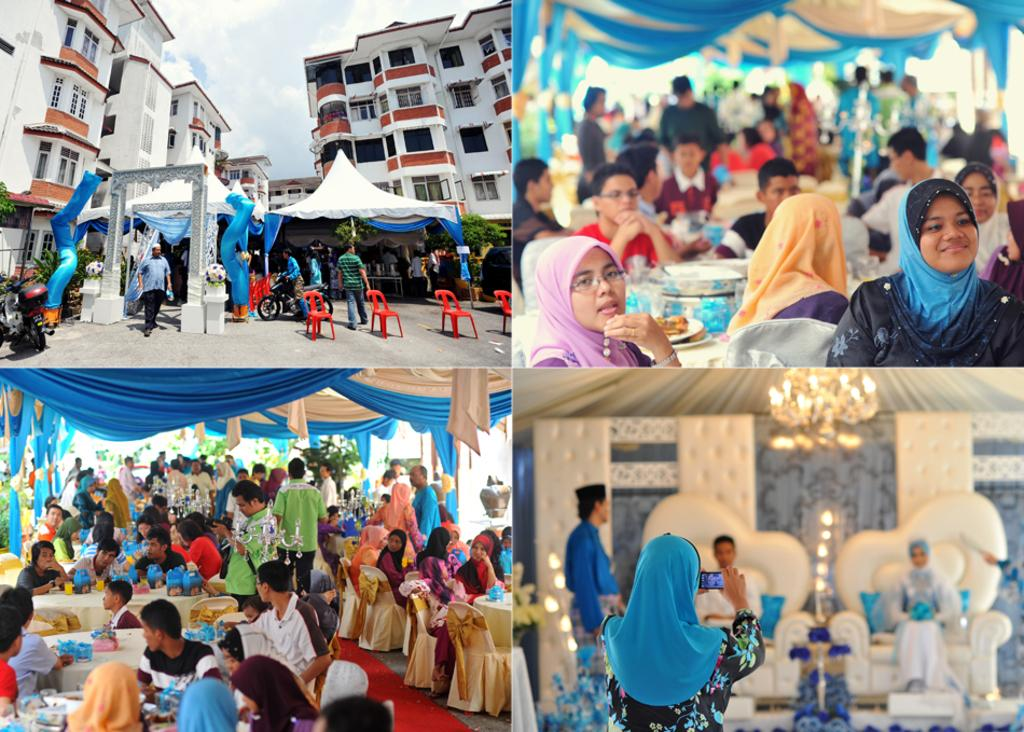What type of artwork is the main subject of the image? The image is a collage containing multiple images. Can you describe the content of the images within the collage? There are people in the images within the collage. What structure can be seen at the left side of the collage? There is a building at the left side of the collage. What type of appliance is being used by the manager in the image? There is no manager or appliance present in the image, as it is a collage containing multiple images without any specific reference to a manager or appliance. 